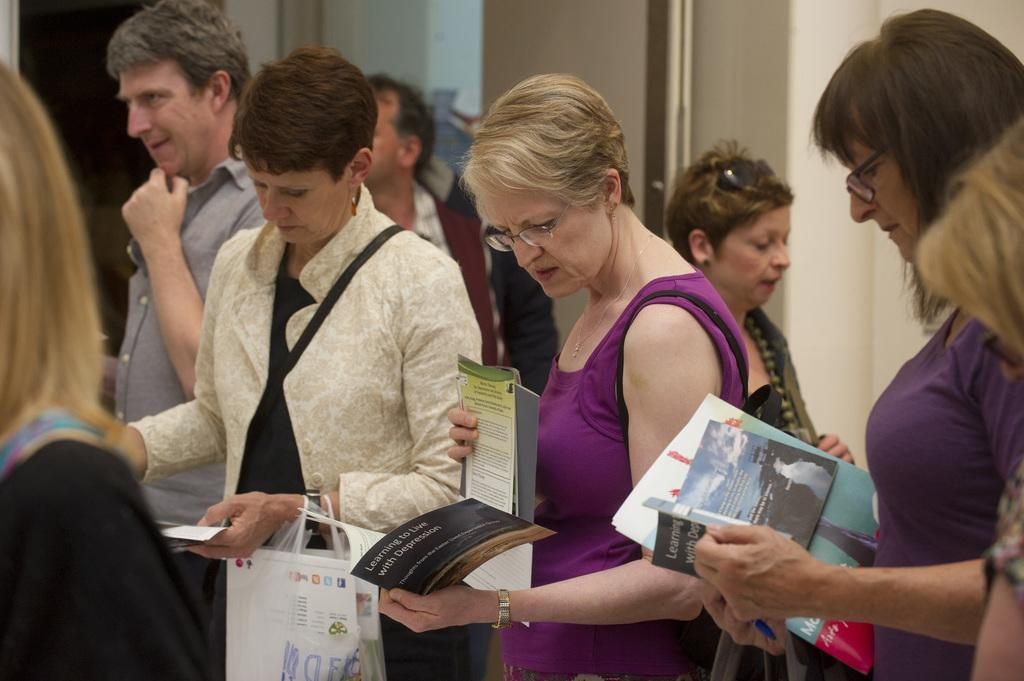How many people are in the image? There are many people in the image. Where are the people located in the image? The people are standing in the center of the image. What are the people holding in their hands? The people are holding books in their hands. What type of trail can be seen in the image? There is no trail present in the image; it features a group of people standing and holding books. 